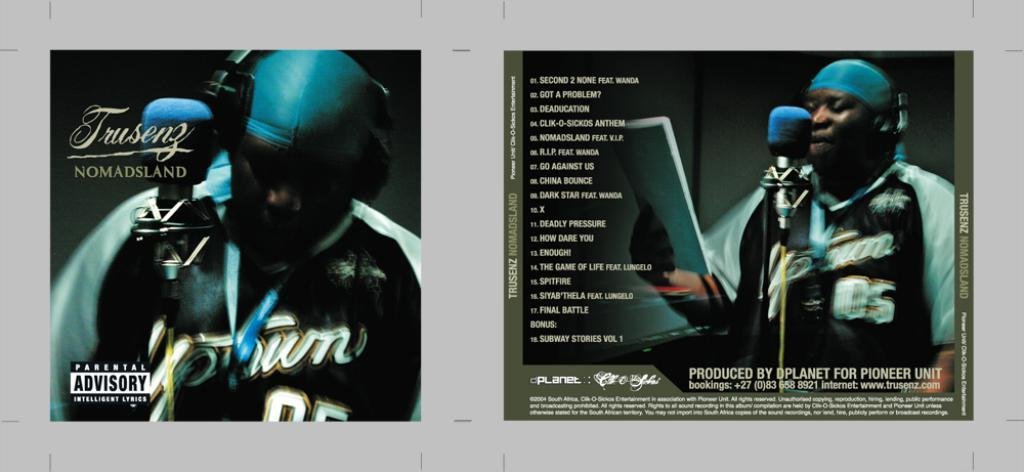<image>
Present a compact description of the photo's key features. A front and back cover of a CD with a man singing on it. 